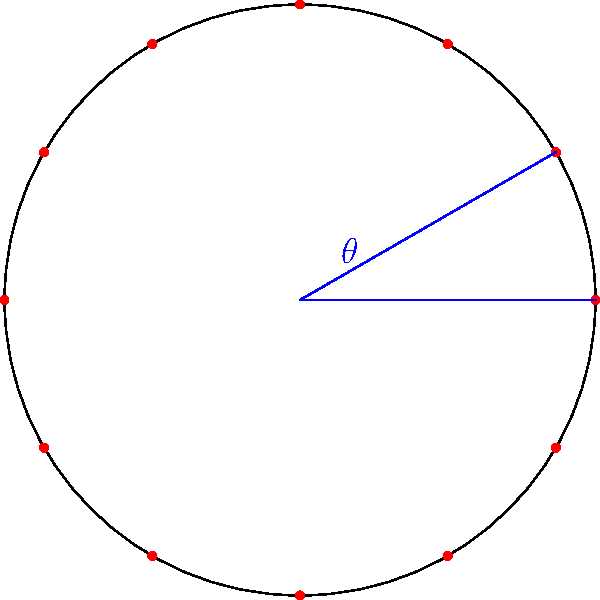As a musician organizing a circular seating arrangement for a 12-piece orchestra, you need to determine the central angle between each musician. Given that the circle represents the seating arrangement and each red dot represents a musician's position, what is the measure of the central angle $\theta$ (in degrees) between any two adjacent musicians? To find the central angle $\theta$ between adjacent musicians, we can follow these steps:

1. Recall that a full circle contains 360°.

2. We have 12 musicians arranged evenly around the circle.

3. To find the angle between each musician, we need to divide the total degrees in a circle by the number of musicians:

   $$\theta = \frac{360°}{12}$$

4. Perform the division:
   
   $$\theta = 30°$$

This means that each musician is separated by a 30° angle at the center of the circle.

As a musician, understanding this arrangement can help you visualize the spacing and potentially the sound projection of each instrument in the ensemble.
Answer: $30°$ 